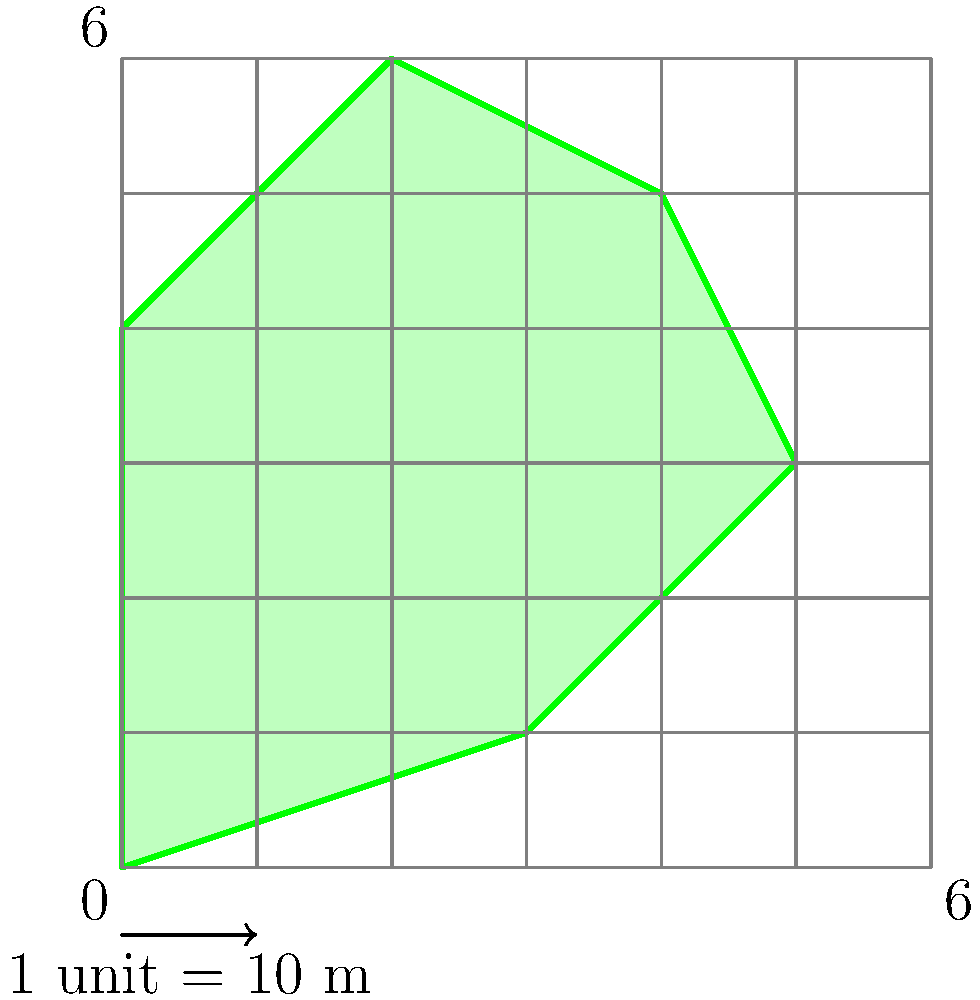As a landscape architect, you're tasked with calculating the area of an irregularly shaped field on a farmer's property. Using the grid overlay provided, where each square represents 100 square meters (10m x 10m), estimate the total area of the field in square meters. Round your answer to the nearest 100 square meters. To estimate the area of the irregular field using the grid method, we'll follow these steps:

1. Count the number of full squares within the field:
   There are approximately 11 full squares.

2. Count the number of partial squares:
   There are about 13 partial squares.

3. Estimate the total number of squares:
   Full squares + (Partial squares ÷ 2) = Total squares
   $11 + (13 \div 2) = 11 + 6.5 = 17.5$ squares

4. Calculate the area:
   Each square represents 100 m², so:
   $\text{Area} = 17.5 \times 100 \text{ m}² = 1750 \text{ m}²$

5. Round to the nearest 100 square meters:
   $1750 \text{ m}²$ rounds to $1800 \text{ m}²$

Therefore, the estimated area of the field is 1800 square meters.
Answer: 1800 m² 